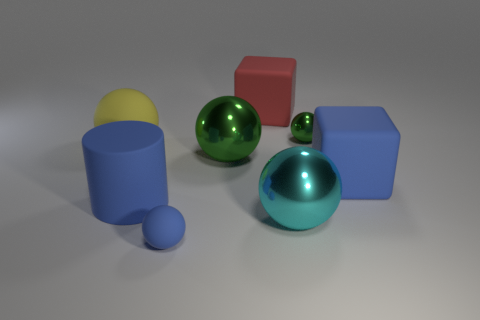There is another metallic ball that is the same size as the blue sphere; what is its color? green 